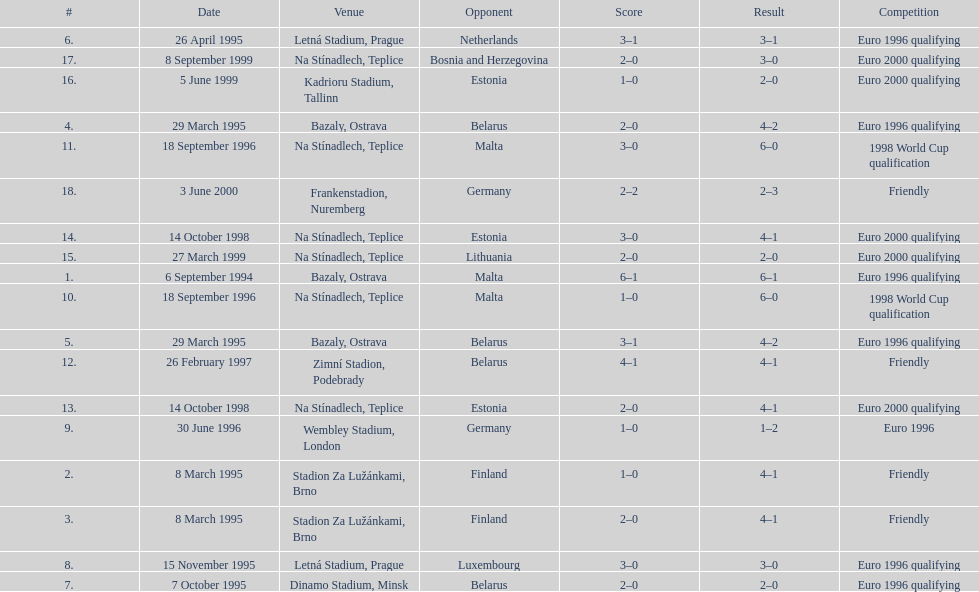How many games took place in ostrava? 2. 